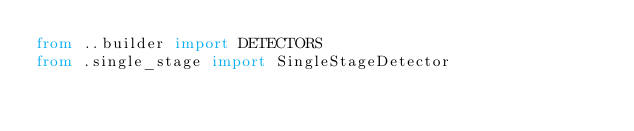Convert code to text. <code><loc_0><loc_0><loc_500><loc_500><_Python_>from ..builder import DETECTORS
from .single_stage import SingleStageDetector

</code> 